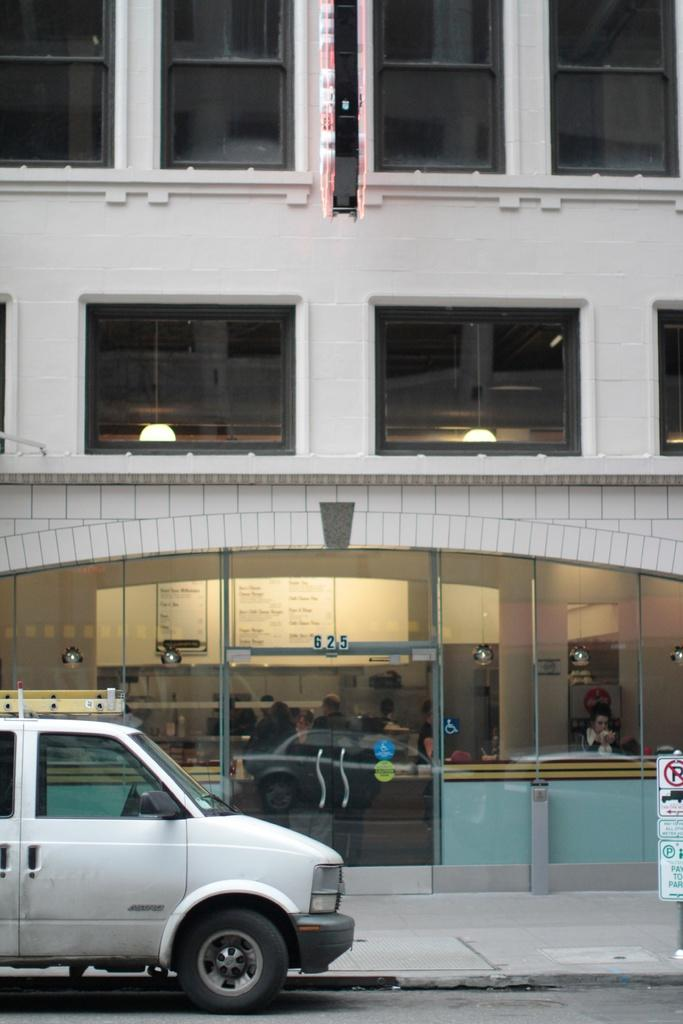What is the main subject of the image? The main subject of the image is a car. What is the car's current status in the image? The car is parked in the image. What else can be seen in the image besides the car? There is a building in the image. What type of credit can be seen being exchanged between the car and the building in the image? There is no credit exchange or any indication of a transaction between the car and the building in the image. 